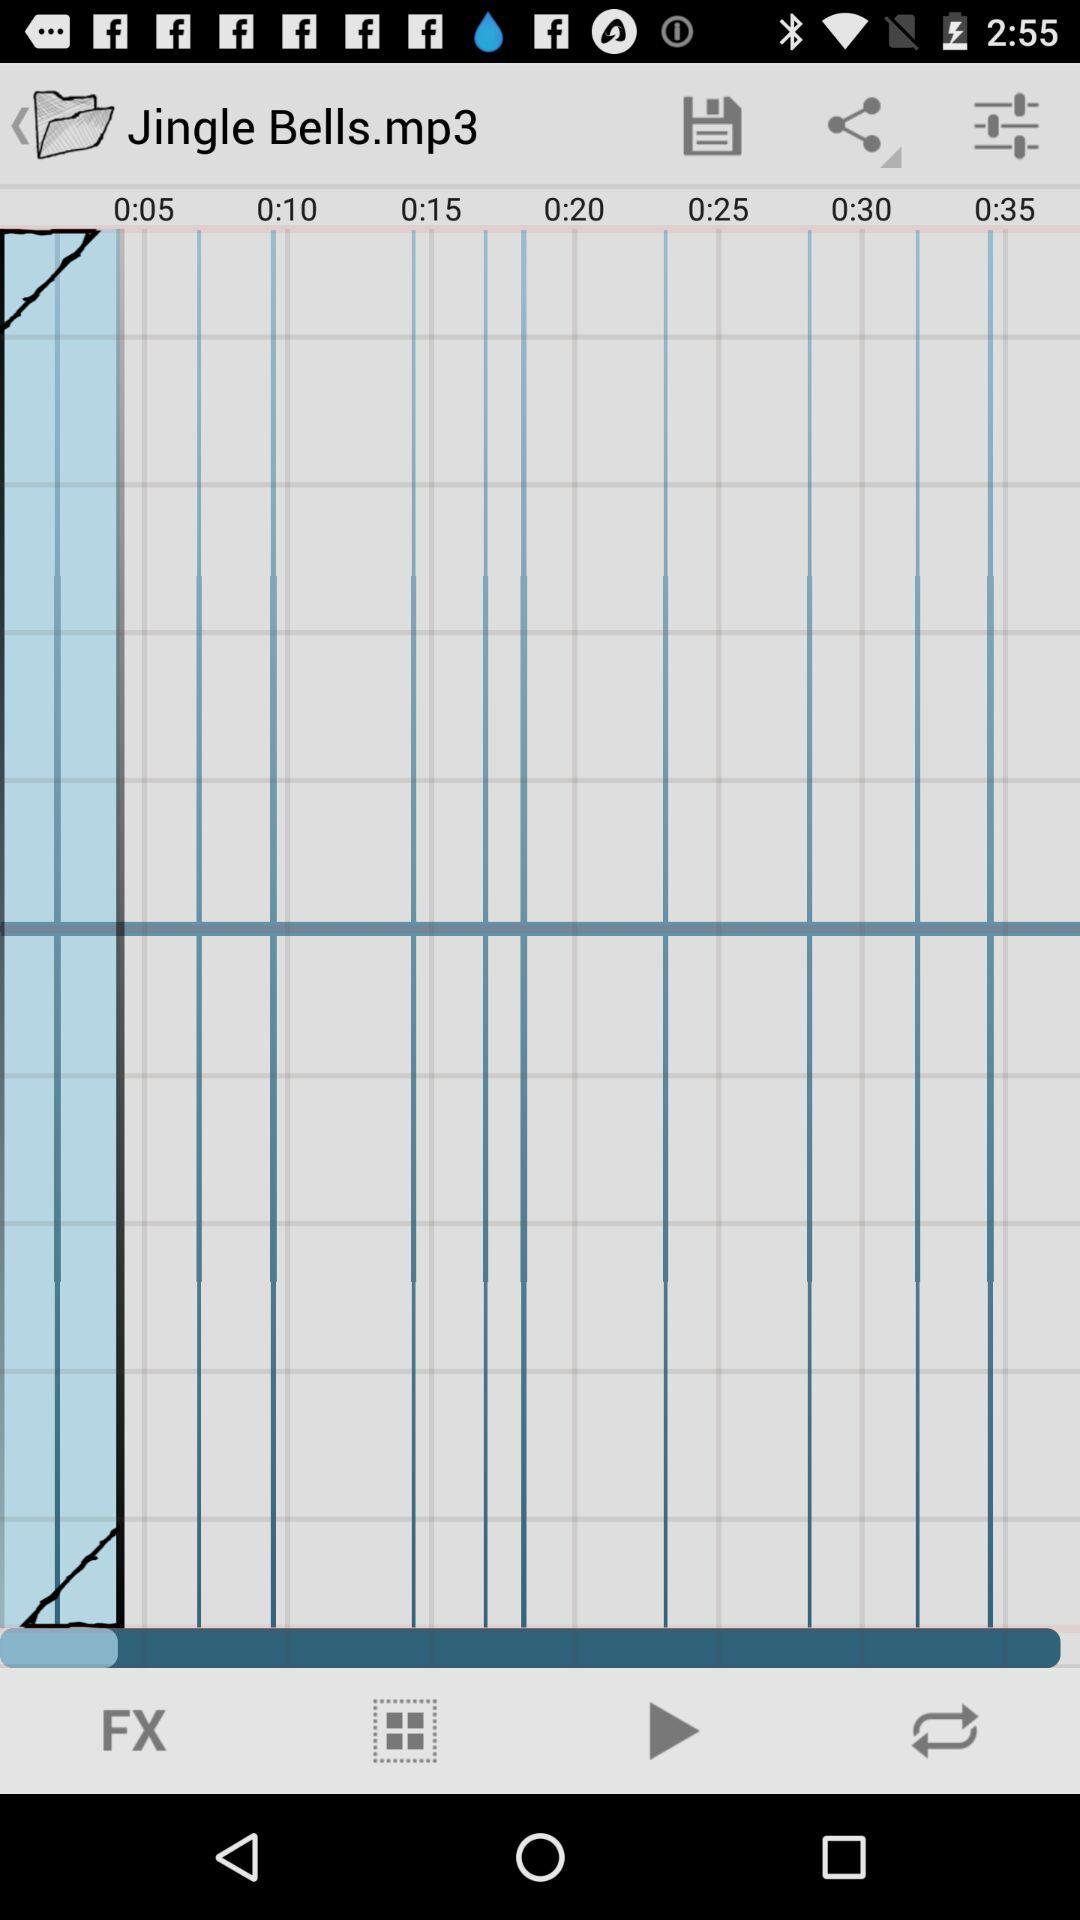How many seconds are shown on the timeline?
Answer the question using a single word or phrase. 35 